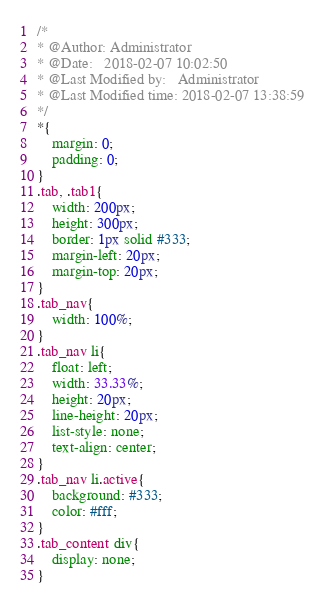Convert code to text. <code><loc_0><loc_0><loc_500><loc_500><_CSS_>/*
* @Author: Administrator
* @Date:   2018-02-07 10:02:50
* @Last Modified by:   Administrator
* @Last Modified time: 2018-02-07 13:38:59
*/
*{
	margin: 0;
	padding: 0;
}
.tab, .tab1{
	width: 200px;
	height: 300px;
	border: 1px solid #333;
	margin-left: 20px;
	margin-top: 20px;
}
.tab_nav{
	width: 100%;
}
.tab_nav li{
	float: left;
	width: 33.33%;
	height: 20px;
	line-height: 20px;
	list-style: none;
	text-align: center;
}
.tab_nav li.active{
	background: #333;
	color: #fff;
}
.tab_content div{
	display: none;
}</code> 